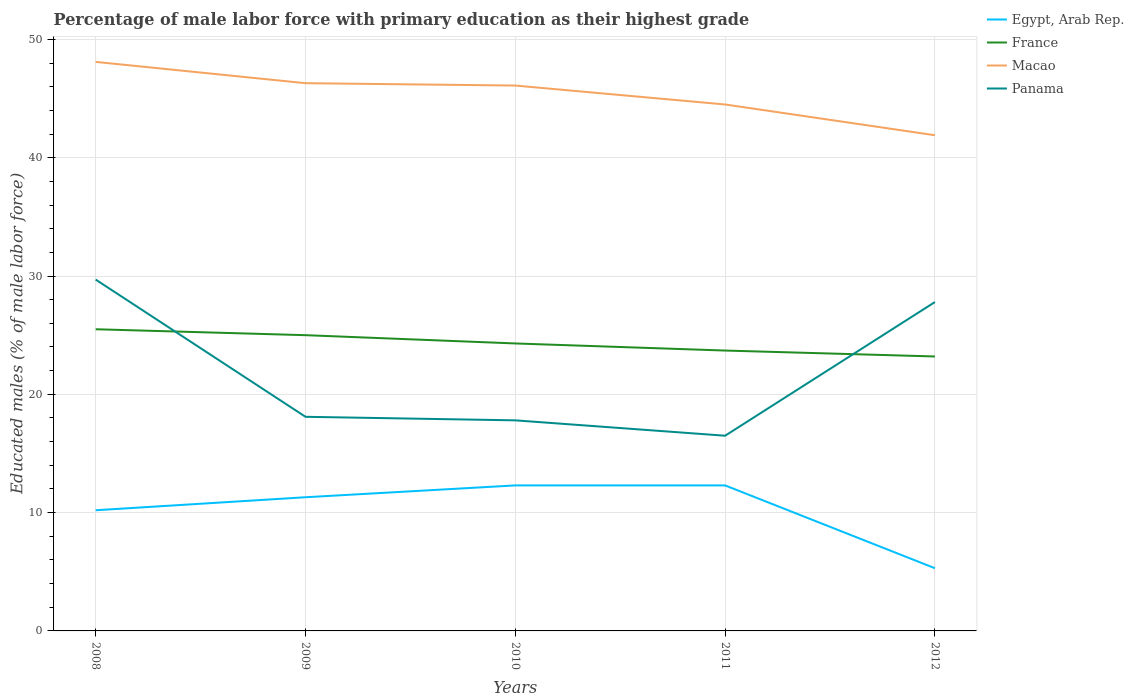Is the number of lines equal to the number of legend labels?
Provide a short and direct response. Yes. Across all years, what is the maximum percentage of male labor force with primary education in Macao?
Provide a short and direct response. 41.9. In which year was the percentage of male labor force with primary education in France maximum?
Your response must be concise. 2012. What is the total percentage of male labor force with primary education in Panama in the graph?
Your response must be concise. -9.7. What is the difference between the highest and the second highest percentage of male labor force with primary education in Panama?
Give a very brief answer. 13.2. What is the difference between the highest and the lowest percentage of male labor force with primary education in Macao?
Ensure brevity in your answer.  3. Is the percentage of male labor force with primary education in Macao strictly greater than the percentage of male labor force with primary education in Egypt, Arab Rep. over the years?
Provide a succinct answer. No. How many lines are there?
Offer a very short reply. 4. What is the difference between two consecutive major ticks on the Y-axis?
Your response must be concise. 10. Are the values on the major ticks of Y-axis written in scientific E-notation?
Ensure brevity in your answer.  No. What is the title of the graph?
Your answer should be compact. Percentage of male labor force with primary education as their highest grade. Does "Andorra" appear as one of the legend labels in the graph?
Ensure brevity in your answer.  No. What is the label or title of the X-axis?
Make the answer very short. Years. What is the label or title of the Y-axis?
Your response must be concise. Educated males (% of male labor force). What is the Educated males (% of male labor force) in Egypt, Arab Rep. in 2008?
Your answer should be compact. 10.2. What is the Educated males (% of male labor force) of Macao in 2008?
Your answer should be compact. 48.1. What is the Educated males (% of male labor force) of Panama in 2008?
Your answer should be compact. 29.7. What is the Educated males (% of male labor force) in Egypt, Arab Rep. in 2009?
Your answer should be compact. 11.3. What is the Educated males (% of male labor force) of Macao in 2009?
Ensure brevity in your answer.  46.3. What is the Educated males (% of male labor force) of Panama in 2009?
Offer a very short reply. 18.1. What is the Educated males (% of male labor force) of Egypt, Arab Rep. in 2010?
Your answer should be very brief. 12.3. What is the Educated males (% of male labor force) in France in 2010?
Give a very brief answer. 24.3. What is the Educated males (% of male labor force) in Macao in 2010?
Your answer should be very brief. 46.1. What is the Educated males (% of male labor force) of Panama in 2010?
Your answer should be compact. 17.8. What is the Educated males (% of male labor force) of Egypt, Arab Rep. in 2011?
Offer a very short reply. 12.3. What is the Educated males (% of male labor force) in France in 2011?
Keep it short and to the point. 23.7. What is the Educated males (% of male labor force) in Macao in 2011?
Offer a terse response. 44.5. What is the Educated males (% of male labor force) in Egypt, Arab Rep. in 2012?
Your answer should be very brief. 5.3. What is the Educated males (% of male labor force) of France in 2012?
Provide a succinct answer. 23.2. What is the Educated males (% of male labor force) of Macao in 2012?
Provide a succinct answer. 41.9. What is the Educated males (% of male labor force) of Panama in 2012?
Your answer should be compact. 27.8. Across all years, what is the maximum Educated males (% of male labor force) in Egypt, Arab Rep.?
Provide a short and direct response. 12.3. Across all years, what is the maximum Educated males (% of male labor force) of France?
Your response must be concise. 25.5. Across all years, what is the maximum Educated males (% of male labor force) in Macao?
Make the answer very short. 48.1. Across all years, what is the maximum Educated males (% of male labor force) in Panama?
Keep it short and to the point. 29.7. Across all years, what is the minimum Educated males (% of male labor force) of Egypt, Arab Rep.?
Give a very brief answer. 5.3. Across all years, what is the minimum Educated males (% of male labor force) of France?
Provide a short and direct response. 23.2. Across all years, what is the minimum Educated males (% of male labor force) of Macao?
Make the answer very short. 41.9. What is the total Educated males (% of male labor force) in Egypt, Arab Rep. in the graph?
Ensure brevity in your answer.  51.4. What is the total Educated males (% of male labor force) of France in the graph?
Keep it short and to the point. 121.7. What is the total Educated males (% of male labor force) in Macao in the graph?
Offer a terse response. 226.9. What is the total Educated males (% of male labor force) of Panama in the graph?
Keep it short and to the point. 109.9. What is the difference between the Educated males (% of male labor force) of Egypt, Arab Rep. in 2008 and that in 2009?
Your answer should be compact. -1.1. What is the difference between the Educated males (% of male labor force) of France in 2008 and that in 2009?
Your answer should be compact. 0.5. What is the difference between the Educated males (% of male labor force) of Panama in 2008 and that in 2009?
Offer a very short reply. 11.6. What is the difference between the Educated males (% of male labor force) in Macao in 2008 and that in 2010?
Provide a succinct answer. 2. What is the difference between the Educated males (% of male labor force) of Panama in 2008 and that in 2010?
Offer a very short reply. 11.9. What is the difference between the Educated males (% of male labor force) in France in 2008 and that in 2011?
Offer a terse response. 1.8. What is the difference between the Educated males (% of male labor force) in Macao in 2008 and that in 2011?
Your response must be concise. 3.6. What is the difference between the Educated males (% of male labor force) in France in 2008 and that in 2012?
Offer a very short reply. 2.3. What is the difference between the Educated males (% of male labor force) in Macao in 2008 and that in 2012?
Offer a terse response. 6.2. What is the difference between the Educated males (% of male labor force) in Panama in 2008 and that in 2012?
Make the answer very short. 1.9. What is the difference between the Educated males (% of male labor force) of Macao in 2009 and that in 2010?
Offer a terse response. 0.2. What is the difference between the Educated males (% of male labor force) of Panama in 2009 and that in 2011?
Offer a terse response. 1.6. What is the difference between the Educated males (% of male labor force) of Panama in 2009 and that in 2012?
Make the answer very short. -9.7. What is the difference between the Educated males (% of male labor force) of Macao in 2010 and that in 2011?
Offer a terse response. 1.6. What is the difference between the Educated males (% of male labor force) in Panama in 2010 and that in 2012?
Your answer should be very brief. -10. What is the difference between the Educated males (% of male labor force) in Egypt, Arab Rep. in 2011 and that in 2012?
Your answer should be very brief. 7. What is the difference between the Educated males (% of male labor force) in France in 2011 and that in 2012?
Your answer should be compact. 0.5. What is the difference between the Educated males (% of male labor force) of Panama in 2011 and that in 2012?
Your answer should be very brief. -11.3. What is the difference between the Educated males (% of male labor force) in Egypt, Arab Rep. in 2008 and the Educated males (% of male labor force) in France in 2009?
Provide a short and direct response. -14.8. What is the difference between the Educated males (% of male labor force) of Egypt, Arab Rep. in 2008 and the Educated males (% of male labor force) of Macao in 2009?
Provide a succinct answer. -36.1. What is the difference between the Educated males (% of male labor force) of Egypt, Arab Rep. in 2008 and the Educated males (% of male labor force) of Panama in 2009?
Your answer should be very brief. -7.9. What is the difference between the Educated males (% of male labor force) in France in 2008 and the Educated males (% of male labor force) in Macao in 2009?
Give a very brief answer. -20.8. What is the difference between the Educated males (% of male labor force) in Egypt, Arab Rep. in 2008 and the Educated males (% of male labor force) in France in 2010?
Offer a terse response. -14.1. What is the difference between the Educated males (% of male labor force) of Egypt, Arab Rep. in 2008 and the Educated males (% of male labor force) of Macao in 2010?
Offer a terse response. -35.9. What is the difference between the Educated males (% of male labor force) in France in 2008 and the Educated males (% of male labor force) in Macao in 2010?
Provide a short and direct response. -20.6. What is the difference between the Educated males (% of male labor force) of Macao in 2008 and the Educated males (% of male labor force) of Panama in 2010?
Make the answer very short. 30.3. What is the difference between the Educated males (% of male labor force) in Egypt, Arab Rep. in 2008 and the Educated males (% of male labor force) in Macao in 2011?
Provide a short and direct response. -34.3. What is the difference between the Educated males (% of male labor force) of Egypt, Arab Rep. in 2008 and the Educated males (% of male labor force) of Panama in 2011?
Your answer should be very brief. -6.3. What is the difference between the Educated males (% of male labor force) in France in 2008 and the Educated males (% of male labor force) in Panama in 2011?
Your answer should be very brief. 9. What is the difference between the Educated males (% of male labor force) of Macao in 2008 and the Educated males (% of male labor force) of Panama in 2011?
Your response must be concise. 31.6. What is the difference between the Educated males (% of male labor force) in Egypt, Arab Rep. in 2008 and the Educated males (% of male labor force) in France in 2012?
Offer a terse response. -13. What is the difference between the Educated males (% of male labor force) of Egypt, Arab Rep. in 2008 and the Educated males (% of male labor force) of Macao in 2012?
Provide a succinct answer. -31.7. What is the difference between the Educated males (% of male labor force) in Egypt, Arab Rep. in 2008 and the Educated males (% of male labor force) in Panama in 2012?
Ensure brevity in your answer.  -17.6. What is the difference between the Educated males (% of male labor force) in France in 2008 and the Educated males (% of male labor force) in Macao in 2012?
Ensure brevity in your answer.  -16.4. What is the difference between the Educated males (% of male labor force) of France in 2008 and the Educated males (% of male labor force) of Panama in 2012?
Make the answer very short. -2.3. What is the difference between the Educated males (% of male labor force) of Macao in 2008 and the Educated males (% of male labor force) of Panama in 2012?
Offer a terse response. 20.3. What is the difference between the Educated males (% of male labor force) in Egypt, Arab Rep. in 2009 and the Educated males (% of male labor force) in Macao in 2010?
Your answer should be compact. -34.8. What is the difference between the Educated males (% of male labor force) in Egypt, Arab Rep. in 2009 and the Educated males (% of male labor force) in Panama in 2010?
Provide a succinct answer. -6.5. What is the difference between the Educated males (% of male labor force) in France in 2009 and the Educated males (% of male labor force) in Macao in 2010?
Make the answer very short. -21.1. What is the difference between the Educated males (% of male labor force) of Macao in 2009 and the Educated males (% of male labor force) of Panama in 2010?
Your response must be concise. 28.5. What is the difference between the Educated males (% of male labor force) of Egypt, Arab Rep. in 2009 and the Educated males (% of male labor force) of Macao in 2011?
Give a very brief answer. -33.2. What is the difference between the Educated males (% of male labor force) in France in 2009 and the Educated males (% of male labor force) in Macao in 2011?
Your answer should be very brief. -19.5. What is the difference between the Educated males (% of male labor force) in Macao in 2009 and the Educated males (% of male labor force) in Panama in 2011?
Your answer should be very brief. 29.8. What is the difference between the Educated males (% of male labor force) in Egypt, Arab Rep. in 2009 and the Educated males (% of male labor force) in France in 2012?
Ensure brevity in your answer.  -11.9. What is the difference between the Educated males (% of male labor force) of Egypt, Arab Rep. in 2009 and the Educated males (% of male labor force) of Macao in 2012?
Your answer should be very brief. -30.6. What is the difference between the Educated males (% of male labor force) in Egypt, Arab Rep. in 2009 and the Educated males (% of male labor force) in Panama in 2012?
Offer a terse response. -16.5. What is the difference between the Educated males (% of male labor force) of France in 2009 and the Educated males (% of male labor force) of Macao in 2012?
Your answer should be compact. -16.9. What is the difference between the Educated males (% of male labor force) in Egypt, Arab Rep. in 2010 and the Educated males (% of male labor force) in France in 2011?
Provide a short and direct response. -11.4. What is the difference between the Educated males (% of male labor force) of Egypt, Arab Rep. in 2010 and the Educated males (% of male labor force) of Macao in 2011?
Provide a short and direct response. -32.2. What is the difference between the Educated males (% of male labor force) in France in 2010 and the Educated males (% of male labor force) in Macao in 2011?
Keep it short and to the point. -20.2. What is the difference between the Educated males (% of male labor force) in France in 2010 and the Educated males (% of male labor force) in Panama in 2011?
Your answer should be very brief. 7.8. What is the difference between the Educated males (% of male labor force) in Macao in 2010 and the Educated males (% of male labor force) in Panama in 2011?
Your answer should be compact. 29.6. What is the difference between the Educated males (% of male labor force) of Egypt, Arab Rep. in 2010 and the Educated males (% of male labor force) of Macao in 2012?
Your answer should be very brief. -29.6. What is the difference between the Educated males (% of male labor force) in Egypt, Arab Rep. in 2010 and the Educated males (% of male labor force) in Panama in 2012?
Offer a terse response. -15.5. What is the difference between the Educated males (% of male labor force) in France in 2010 and the Educated males (% of male labor force) in Macao in 2012?
Your response must be concise. -17.6. What is the difference between the Educated males (% of male labor force) in France in 2010 and the Educated males (% of male labor force) in Panama in 2012?
Offer a very short reply. -3.5. What is the difference between the Educated males (% of male labor force) in Egypt, Arab Rep. in 2011 and the Educated males (% of male labor force) in Macao in 2012?
Your answer should be very brief. -29.6. What is the difference between the Educated males (% of male labor force) of Egypt, Arab Rep. in 2011 and the Educated males (% of male labor force) of Panama in 2012?
Your response must be concise. -15.5. What is the difference between the Educated males (% of male labor force) of France in 2011 and the Educated males (% of male labor force) of Macao in 2012?
Offer a very short reply. -18.2. What is the average Educated males (% of male labor force) of Egypt, Arab Rep. per year?
Your answer should be very brief. 10.28. What is the average Educated males (% of male labor force) in France per year?
Provide a short and direct response. 24.34. What is the average Educated males (% of male labor force) in Macao per year?
Your response must be concise. 45.38. What is the average Educated males (% of male labor force) of Panama per year?
Give a very brief answer. 21.98. In the year 2008, what is the difference between the Educated males (% of male labor force) in Egypt, Arab Rep. and Educated males (% of male labor force) in France?
Give a very brief answer. -15.3. In the year 2008, what is the difference between the Educated males (% of male labor force) of Egypt, Arab Rep. and Educated males (% of male labor force) of Macao?
Your answer should be very brief. -37.9. In the year 2008, what is the difference between the Educated males (% of male labor force) of Egypt, Arab Rep. and Educated males (% of male labor force) of Panama?
Provide a succinct answer. -19.5. In the year 2008, what is the difference between the Educated males (% of male labor force) of France and Educated males (% of male labor force) of Macao?
Your response must be concise. -22.6. In the year 2009, what is the difference between the Educated males (% of male labor force) in Egypt, Arab Rep. and Educated males (% of male labor force) in France?
Keep it short and to the point. -13.7. In the year 2009, what is the difference between the Educated males (% of male labor force) in Egypt, Arab Rep. and Educated males (% of male labor force) in Macao?
Your answer should be compact. -35. In the year 2009, what is the difference between the Educated males (% of male labor force) of Egypt, Arab Rep. and Educated males (% of male labor force) of Panama?
Ensure brevity in your answer.  -6.8. In the year 2009, what is the difference between the Educated males (% of male labor force) of France and Educated males (% of male labor force) of Macao?
Your response must be concise. -21.3. In the year 2009, what is the difference between the Educated males (% of male labor force) in Macao and Educated males (% of male labor force) in Panama?
Offer a very short reply. 28.2. In the year 2010, what is the difference between the Educated males (% of male labor force) in Egypt, Arab Rep. and Educated males (% of male labor force) in France?
Make the answer very short. -12. In the year 2010, what is the difference between the Educated males (% of male labor force) of Egypt, Arab Rep. and Educated males (% of male labor force) of Macao?
Keep it short and to the point. -33.8. In the year 2010, what is the difference between the Educated males (% of male labor force) in France and Educated males (% of male labor force) in Macao?
Make the answer very short. -21.8. In the year 2010, what is the difference between the Educated males (% of male labor force) of France and Educated males (% of male labor force) of Panama?
Your answer should be very brief. 6.5. In the year 2010, what is the difference between the Educated males (% of male labor force) of Macao and Educated males (% of male labor force) of Panama?
Give a very brief answer. 28.3. In the year 2011, what is the difference between the Educated males (% of male labor force) of Egypt, Arab Rep. and Educated males (% of male labor force) of France?
Your answer should be very brief. -11.4. In the year 2011, what is the difference between the Educated males (% of male labor force) in Egypt, Arab Rep. and Educated males (% of male labor force) in Macao?
Provide a short and direct response. -32.2. In the year 2011, what is the difference between the Educated males (% of male labor force) of Egypt, Arab Rep. and Educated males (% of male labor force) of Panama?
Offer a very short reply. -4.2. In the year 2011, what is the difference between the Educated males (% of male labor force) of France and Educated males (% of male labor force) of Macao?
Your answer should be compact. -20.8. In the year 2011, what is the difference between the Educated males (% of male labor force) of France and Educated males (% of male labor force) of Panama?
Provide a succinct answer. 7.2. In the year 2011, what is the difference between the Educated males (% of male labor force) in Macao and Educated males (% of male labor force) in Panama?
Your response must be concise. 28. In the year 2012, what is the difference between the Educated males (% of male labor force) in Egypt, Arab Rep. and Educated males (% of male labor force) in France?
Provide a succinct answer. -17.9. In the year 2012, what is the difference between the Educated males (% of male labor force) of Egypt, Arab Rep. and Educated males (% of male labor force) of Macao?
Make the answer very short. -36.6. In the year 2012, what is the difference between the Educated males (% of male labor force) of Egypt, Arab Rep. and Educated males (% of male labor force) of Panama?
Your response must be concise. -22.5. In the year 2012, what is the difference between the Educated males (% of male labor force) of France and Educated males (% of male labor force) of Macao?
Make the answer very short. -18.7. What is the ratio of the Educated males (% of male labor force) in Egypt, Arab Rep. in 2008 to that in 2009?
Keep it short and to the point. 0.9. What is the ratio of the Educated males (% of male labor force) of Macao in 2008 to that in 2009?
Offer a terse response. 1.04. What is the ratio of the Educated males (% of male labor force) in Panama in 2008 to that in 2009?
Make the answer very short. 1.64. What is the ratio of the Educated males (% of male labor force) of Egypt, Arab Rep. in 2008 to that in 2010?
Offer a very short reply. 0.83. What is the ratio of the Educated males (% of male labor force) in France in 2008 to that in 2010?
Offer a terse response. 1.05. What is the ratio of the Educated males (% of male labor force) of Macao in 2008 to that in 2010?
Provide a short and direct response. 1.04. What is the ratio of the Educated males (% of male labor force) in Panama in 2008 to that in 2010?
Offer a terse response. 1.67. What is the ratio of the Educated males (% of male labor force) in Egypt, Arab Rep. in 2008 to that in 2011?
Provide a succinct answer. 0.83. What is the ratio of the Educated males (% of male labor force) in France in 2008 to that in 2011?
Offer a terse response. 1.08. What is the ratio of the Educated males (% of male labor force) of Macao in 2008 to that in 2011?
Offer a very short reply. 1.08. What is the ratio of the Educated males (% of male labor force) in Egypt, Arab Rep. in 2008 to that in 2012?
Make the answer very short. 1.92. What is the ratio of the Educated males (% of male labor force) in France in 2008 to that in 2012?
Your answer should be very brief. 1.1. What is the ratio of the Educated males (% of male labor force) in Macao in 2008 to that in 2012?
Keep it short and to the point. 1.15. What is the ratio of the Educated males (% of male labor force) of Panama in 2008 to that in 2012?
Keep it short and to the point. 1.07. What is the ratio of the Educated males (% of male labor force) of Egypt, Arab Rep. in 2009 to that in 2010?
Provide a short and direct response. 0.92. What is the ratio of the Educated males (% of male labor force) of France in 2009 to that in 2010?
Make the answer very short. 1.03. What is the ratio of the Educated males (% of male labor force) of Macao in 2009 to that in 2010?
Offer a very short reply. 1. What is the ratio of the Educated males (% of male labor force) in Panama in 2009 to that in 2010?
Keep it short and to the point. 1.02. What is the ratio of the Educated males (% of male labor force) in Egypt, Arab Rep. in 2009 to that in 2011?
Provide a succinct answer. 0.92. What is the ratio of the Educated males (% of male labor force) of France in 2009 to that in 2011?
Ensure brevity in your answer.  1.05. What is the ratio of the Educated males (% of male labor force) in Macao in 2009 to that in 2011?
Keep it short and to the point. 1.04. What is the ratio of the Educated males (% of male labor force) in Panama in 2009 to that in 2011?
Ensure brevity in your answer.  1.1. What is the ratio of the Educated males (% of male labor force) of Egypt, Arab Rep. in 2009 to that in 2012?
Your answer should be very brief. 2.13. What is the ratio of the Educated males (% of male labor force) of France in 2009 to that in 2012?
Provide a succinct answer. 1.08. What is the ratio of the Educated males (% of male labor force) in Macao in 2009 to that in 2012?
Your response must be concise. 1.1. What is the ratio of the Educated males (% of male labor force) in Panama in 2009 to that in 2012?
Ensure brevity in your answer.  0.65. What is the ratio of the Educated males (% of male labor force) in France in 2010 to that in 2011?
Provide a succinct answer. 1.03. What is the ratio of the Educated males (% of male labor force) in Macao in 2010 to that in 2011?
Provide a succinct answer. 1.04. What is the ratio of the Educated males (% of male labor force) of Panama in 2010 to that in 2011?
Make the answer very short. 1.08. What is the ratio of the Educated males (% of male labor force) of Egypt, Arab Rep. in 2010 to that in 2012?
Your answer should be very brief. 2.32. What is the ratio of the Educated males (% of male labor force) of France in 2010 to that in 2012?
Offer a very short reply. 1.05. What is the ratio of the Educated males (% of male labor force) of Macao in 2010 to that in 2012?
Keep it short and to the point. 1.1. What is the ratio of the Educated males (% of male labor force) in Panama in 2010 to that in 2012?
Provide a succinct answer. 0.64. What is the ratio of the Educated males (% of male labor force) in Egypt, Arab Rep. in 2011 to that in 2012?
Offer a very short reply. 2.32. What is the ratio of the Educated males (% of male labor force) in France in 2011 to that in 2012?
Offer a very short reply. 1.02. What is the ratio of the Educated males (% of male labor force) of Macao in 2011 to that in 2012?
Offer a terse response. 1.06. What is the ratio of the Educated males (% of male labor force) of Panama in 2011 to that in 2012?
Keep it short and to the point. 0.59. What is the difference between the highest and the second highest Educated males (% of male labor force) of Egypt, Arab Rep.?
Ensure brevity in your answer.  0. What is the difference between the highest and the second highest Educated males (% of male labor force) in France?
Your response must be concise. 0.5. What is the difference between the highest and the second highest Educated males (% of male labor force) in Panama?
Keep it short and to the point. 1.9. What is the difference between the highest and the lowest Educated males (% of male labor force) in Macao?
Provide a succinct answer. 6.2. 